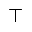<formula> <loc_0><loc_0><loc_500><loc_500>{ \top }</formula> 